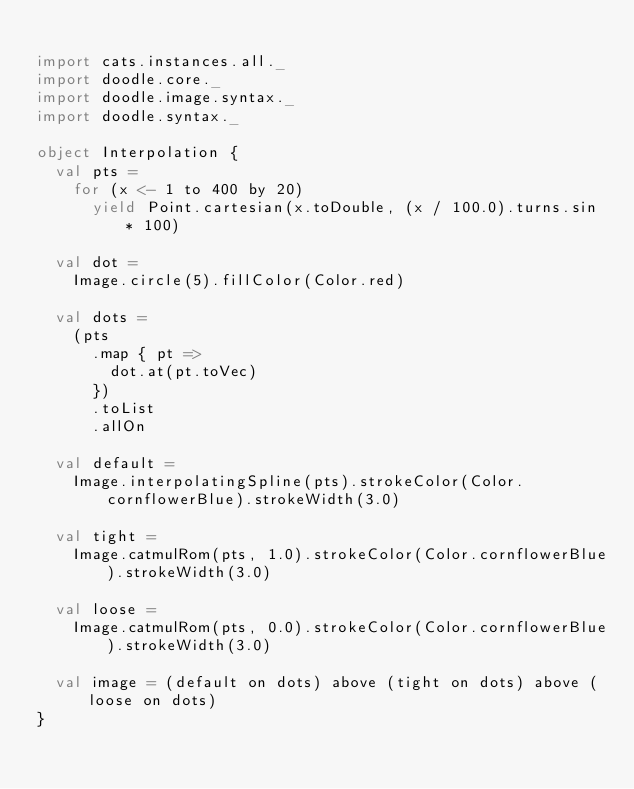Convert code to text. <code><loc_0><loc_0><loc_500><loc_500><_Scala_>
import cats.instances.all._
import doodle.core._
import doodle.image.syntax._
import doodle.syntax._

object Interpolation {
  val pts =
    for (x <- 1 to 400 by 20)
      yield Point.cartesian(x.toDouble, (x / 100.0).turns.sin * 100)

  val dot =
    Image.circle(5).fillColor(Color.red)

  val dots =
    (pts
      .map { pt =>
        dot.at(pt.toVec)
      })
      .toList
      .allOn

  val default =
    Image.interpolatingSpline(pts).strokeColor(Color.cornflowerBlue).strokeWidth(3.0)

  val tight =
    Image.catmulRom(pts, 1.0).strokeColor(Color.cornflowerBlue).strokeWidth(3.0)

  val loose =
    Image.catmulRom(pts, 0.0).strokeColor(Color.cornflowerBlue).strokeWidth(3.0)

  val image = (default on dots) above (tight on dots) above (loose on dots)
}
</code> 